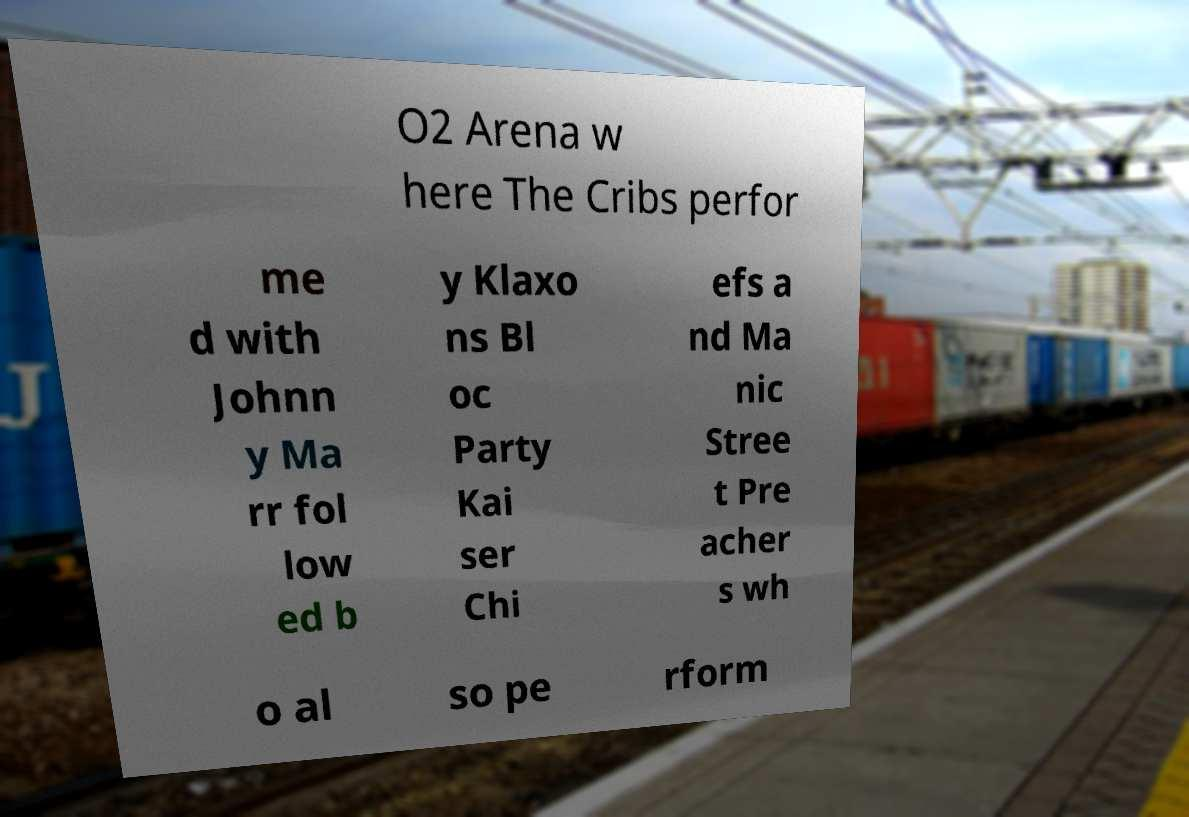Please read and relay the text visible in this image. What does it say? O2 Arena w here The Cribs perfor me d with Johnn y Ma rr fol low ed b y Klaxo ns Bl oc Party Kai ser Chi efs a nd Ma nic Stree t Pre acher s wh o al so pe rform 